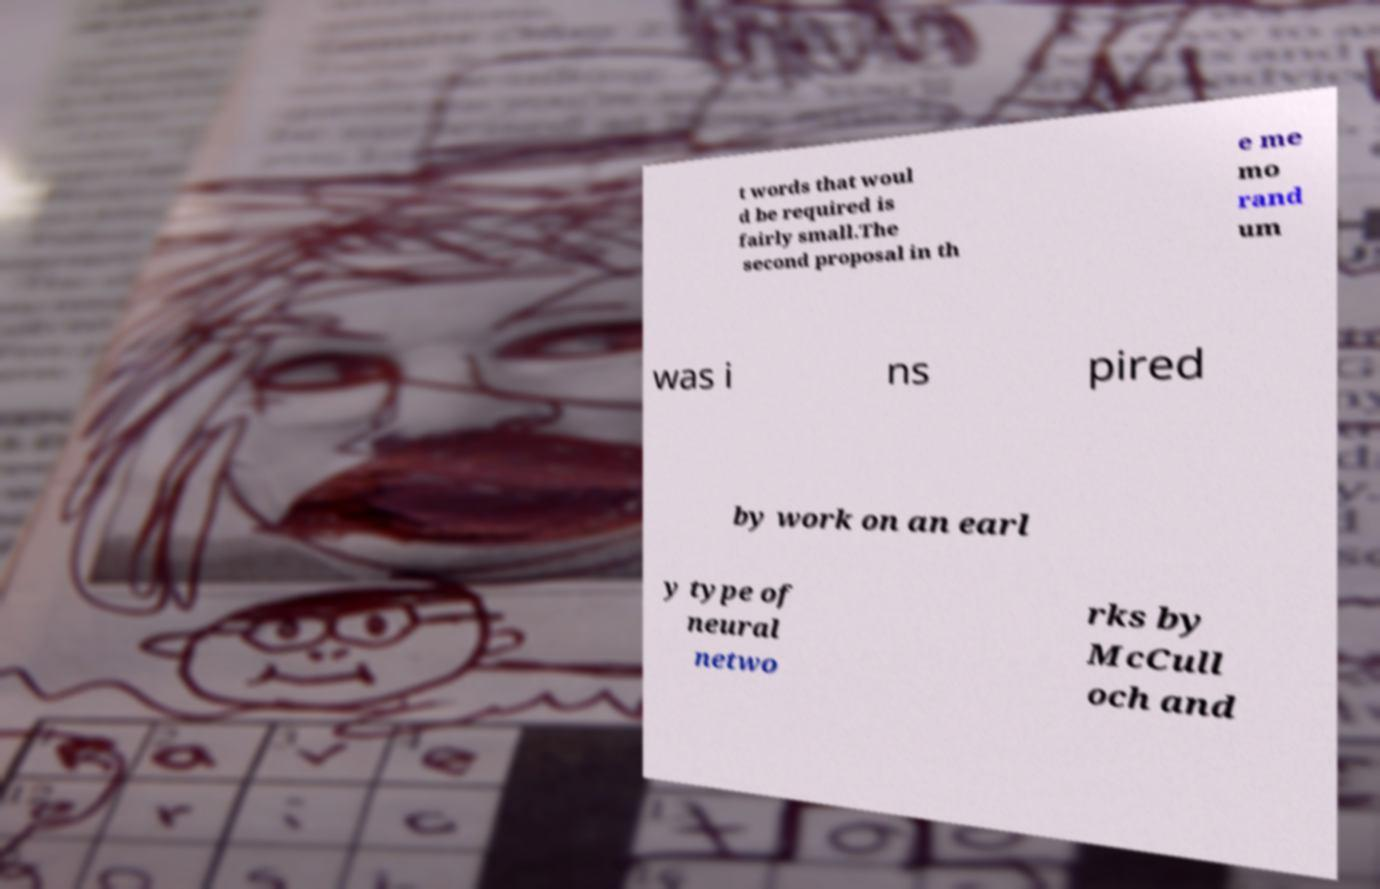Could you assist in decoding the text presented in this image and type it out clearly? t words that woul d be required is fairly small.The second proposal in th e me mo rand um was i ns pired by work on an earl y type of neural netwo rks by McCull och and 